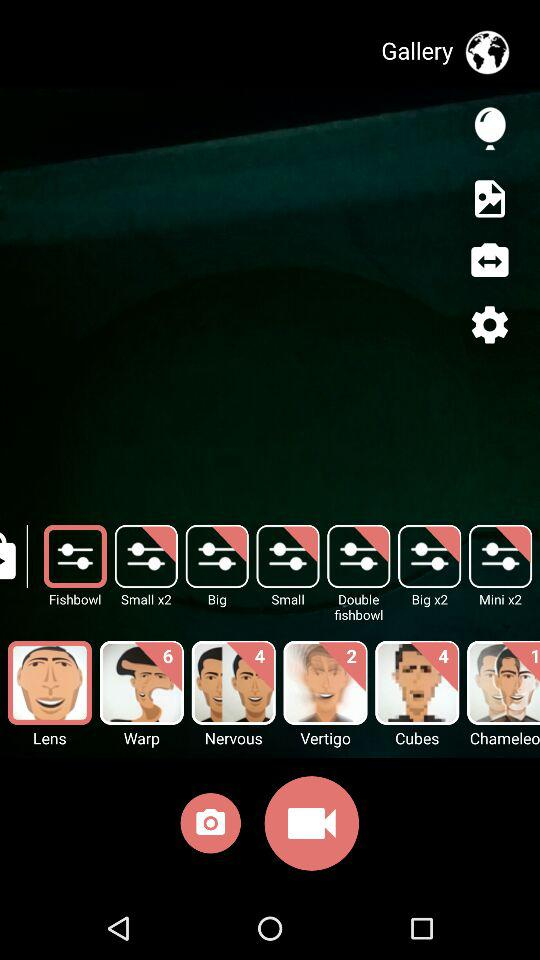How many new features are available for the "Nervous" option? The available new features for the "Nervous" option are 4. 